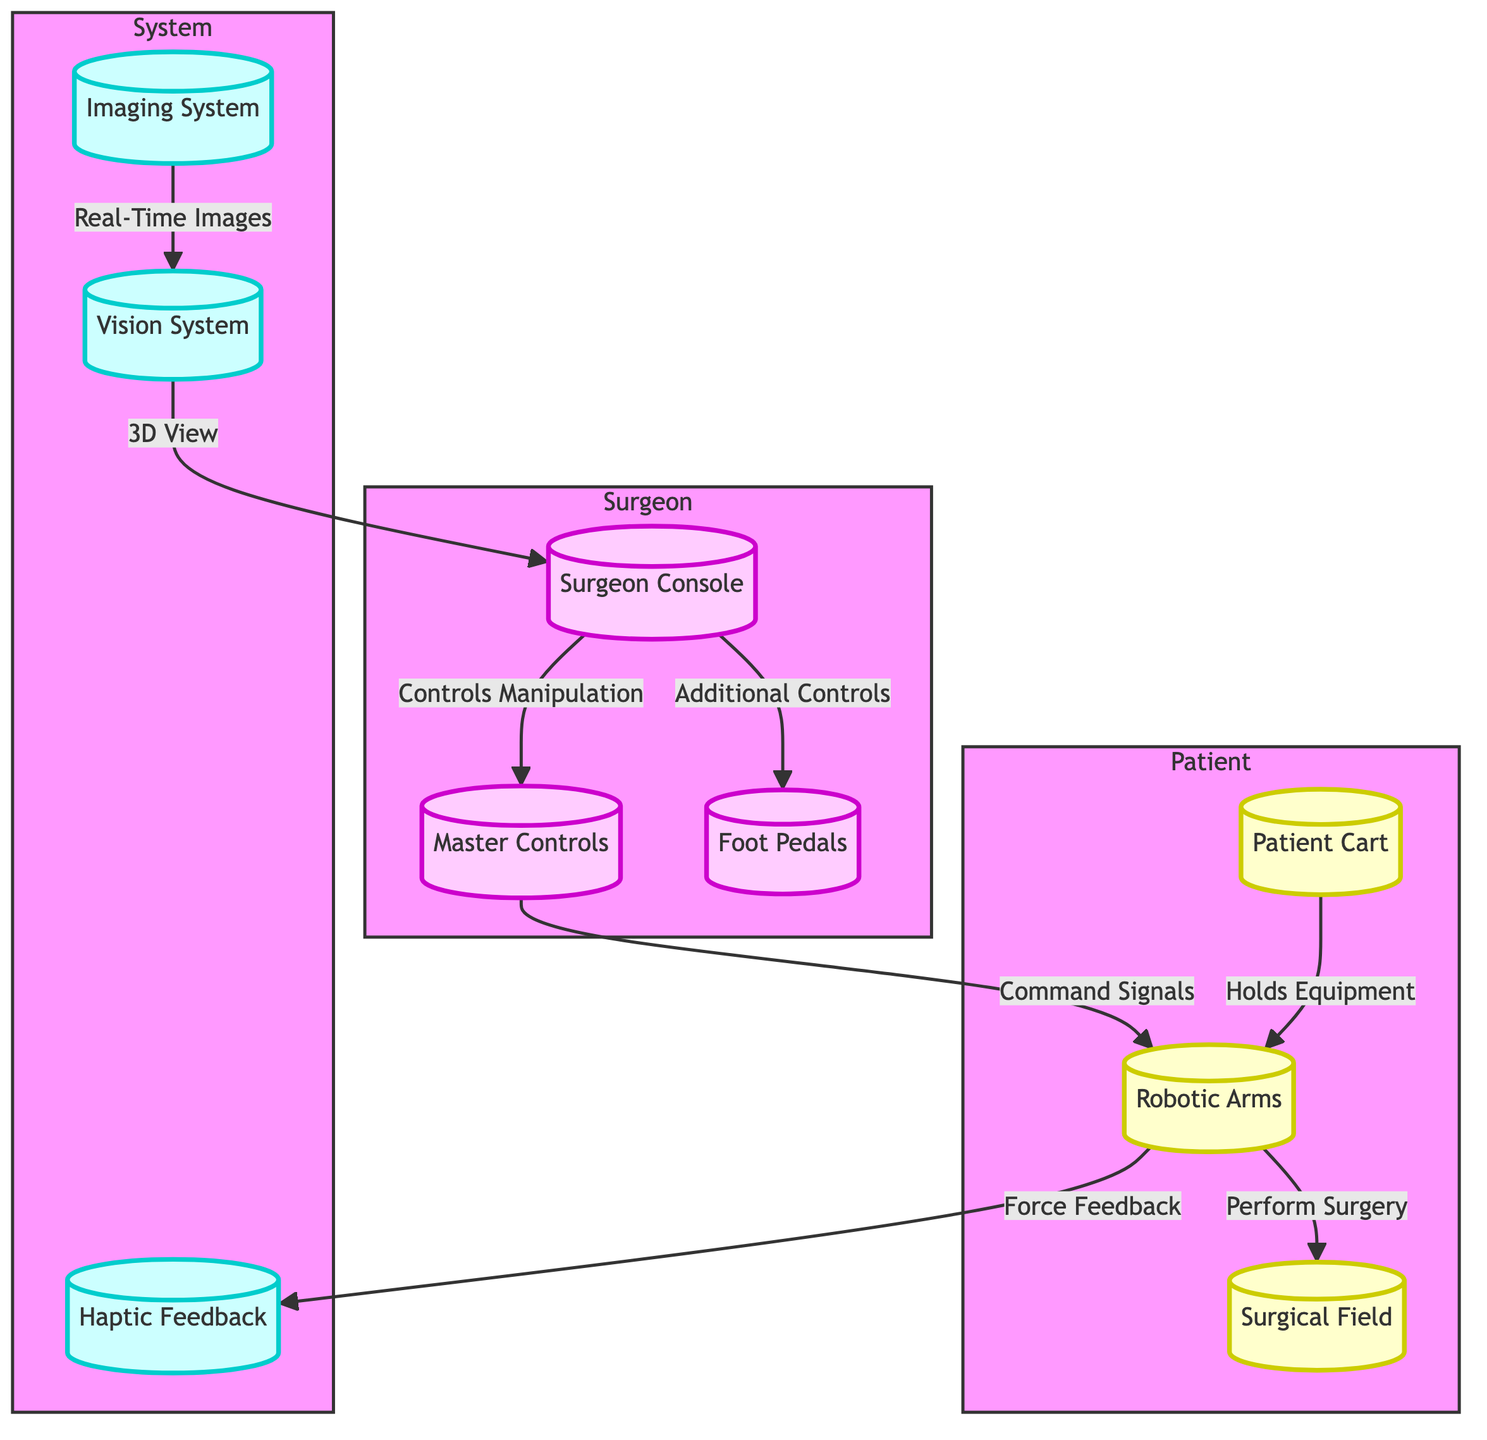What is the initial step in the robotic surgery workflow? The initial step is the interaction between the Surgeon Console and the Master Controls, as indicated by the arrow from the Surgeon Console to Master Controls showing "Controls Manipulation."
Answer: Surgeon Console How many main components are in the Patient subgraph? There are three components in the Patient subgraph which are the Patient Cart, Robotic Arms, and Surgical Field.
Answer: 3 What type of feedback is provided by the Robotic Arms? The type of feedback provided by the Robotic Arms is "Force Feedback," as shown with the directed edge from Robotic Arms to Haptic Feedback.
Answer: Force Feedback Which system provides a 3D view to the Surgeon Console? The Vision System provides a 3D view to the Surgeon Console, indicated by the edge labeled "3D View" from the Vision System to the Surgeon Console.
Answer: Vision System How do imaging systems contribute to the workflow? Imaging Systems contribute by providing "Real-Time Images" to the Vision System, helping to inform the Surgeon Console about the surgical field status. This is shown in the edge leading from Imaging System to Vision System.
Answer: Real-Time Images What is the role of the Foot Pedals in the workflow? The Foot Pedals provide "Additional Controls" as per the directed edge leading from the Surgeon Console to the Foot Pedals, allowing the surgeon to manipulate surgical actions hands-free.
Answer: Additional Controls How does the Master Controls interact with the Robotic Arms? The Master Controls send "Command Signals" to the Robotic Arms, which is indicated by the arrow from Master Controls to Robotic Arms depicting a direct command relationship.
Answer: Command Signals What equipment holds the Robotic Arms? The Patient Cart holds the Robotic Arms, which is explicitly stated in the edge connecting Patient Cart to Robotic Arms labeled "Holds Equipment."
Answer: Patient Cart 